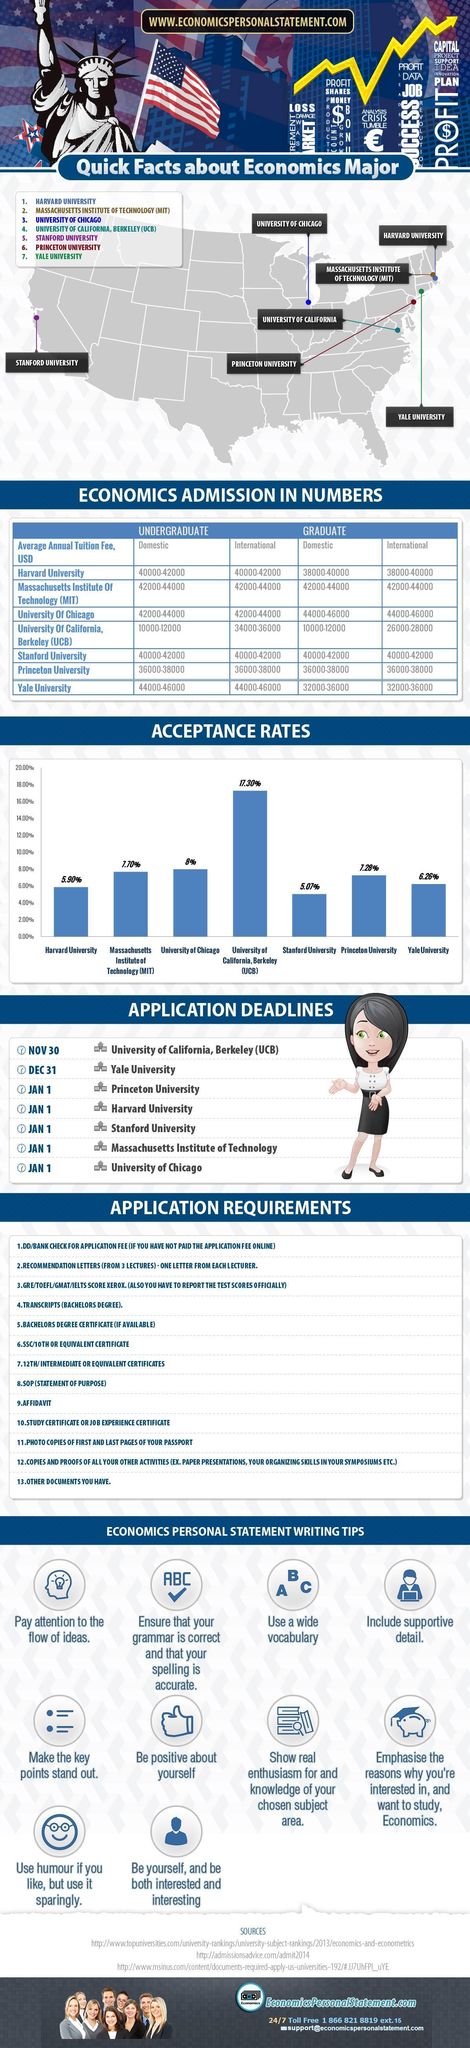What is the application acceptance rate at the Yale University?
Answer the question with a short phrase. 6.26% What is the application acceptance rate at the University of Chicago? 8% What is the average annual tuition fee (in USD) for the graduate program for domestic students at the Harvard University? 38000-40000 What is the average annual tuition fee (in USD) for the graduate program for International students at the Stanford University? 40000-42000 Which university has the highest application acceptance rate in the U.S.? University of California, Berkeley (UCB) Which university has the least application acceptance rate in the U.S.? Stanford University What is the average annual tuition fee (in USD) for the undergraduate program for domestic students at the University of Chicago? 42000-44000 